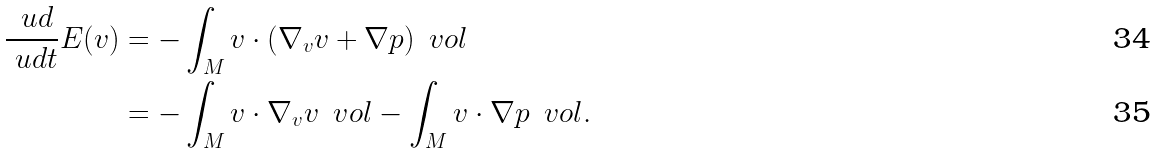<formula> <loc_0><loc_0><loc_500><loc_500>\frac { \ u d } { \ u d t } E ( v ) & = - \int _ { M } v \cdot ( \nabla _ { v } v + \nabla p ) \, \ v o l \\ & = - \int _ { M } v \cdot \nabla _ { v } v \, \ v o l - \int _ { M } v \cdot \nabla p \, \ v o l .</formula> 